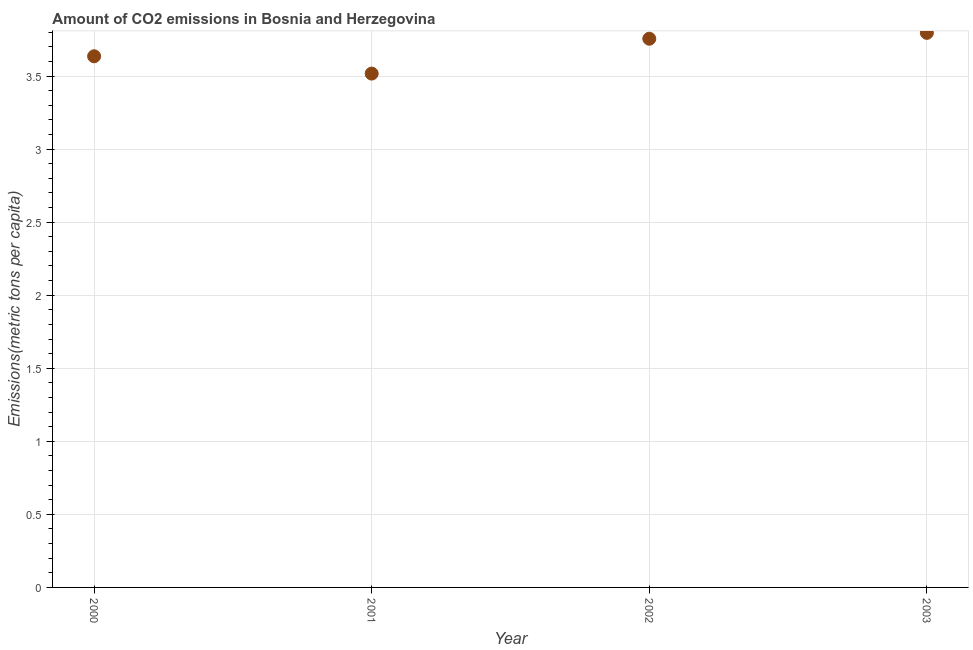What is the amount of co2 emissions in 2000?
Your response must be concise. 3.64. Across all years, what is the maximum amount of co2 emissions?
Your answer should be very brief. 3.8. Across all years, what is the minimum amount of co2 emissions?
Offer a very short reply. 3.52. In which year was the amount of co2 emissions maximum?
Ensure brevity in your answer.  2003. What is the sum of the amount of co2 emissions?
Provide a short and direct response. 14.7. What is the difference between the amount of co2 emissions in 2002 and 2003?
Your response must be concise. -0.04. What is the average amount of co2 emissions per year?
Provide a succinct answer. 3.68. What is the median amount of co2 emissions?
Keep it short and to the point. 3.7. In how many years, is the amount of co2 emissions greater than 1.4 metric tons per capita?
Keep it short and to the point. 4. Do a majority of the years between 2000 and 2002 (inclusive) have amount of co2 emissions greater than 2.8 metric tons per capita?
Provide a succinct answer. Yes. What is the ratio of the amount of co2 emissions in 2001 to that in 2003?
Give a very brief answer. 0.93. Is the amount of co2 emissions in 2001 less than that in 2002?
Offer a very short reply. Yes. What is the difference between the highest and the second highest amount of co2 emissions?
Provide a short and direct response. 0.04. Is the sum of the amount of co2 emissions in 2001 and 2003 greater than the maximum amount of co2 emissions across all years?
Your answer should be compact. Yes. What is the difference between the highest and the lowest amount of co2 emissions?
Your response must be concise. 0.28. In how many years, is the amount of co2 emissions greater than the average amount of co2 emissions taken over all years?
Provide a succinct answer. 2. How many dotlines are there?
Your response must be concise. 1. How many years are there in the graph?
Offer a terse response. 4. What is the difference between two consecutive major ticks on the Y-axis?
Offer a very short reply. 0.5. What is the title of the graph?
Keep it short and to the point. Amount of CO2 emissions in Bosnia and Herzegovina. What is the label or title of the X-axis?
Keep it short and to the point. Year. What is the label or title of the Y-axis?
Provide a short and direct response. Emissions(metric tons per capita). What is the Emissions(metric tons per capita) in 2000?
Provide a short and direct response. 3.64. What is the Emissions(metric tons per capita) in 2001?
Give a very brief answer. 3.52. What is the Emissions(metric tons per capita) in 2002?
Ensure brevity in your answer.  3.76. What is the Emissions(metric tons per capita) in 2003?
Keep it short and to the point. 3.8. What is the difference between the Emissions(metric tons per capita) in 2000 and 2001?
Ensure brevity in your answer.  0.12. What is the difference between the Emissions(metric tons per capita) in 2000 and 2002?
Your response must be concise. -0.12. What is the difference between the Emissions(metric tons per capita) in 2000 and 2003?
Offer a very short reply. -0.16. What is the difference between the Emissions(metric tons per capita) in 2001 and 2002?
Your answer should be very brief. -0.24. What is the difference between the Emissions(metric tons per capita) in 2001 and 2003?
Provide a succinct answer. -0.28. What is the difference between the Emissions(metric tons per capita) in 2002 and 2003?
Your answer should be compact. -0.04. What is the ratio of the Emissions(metric tons per capita) in 2000 to that in 2001?
Keep it short and to the point. 1.03. What is the ratio of the Emissions(metric tons per capita) in 2000 to that in 2003?
Ensure brevity in your answer.  0.96. What is the ratio of the Emissions(metric tons per capita) in 2001 to that in 2002?
Give a very brief answer. 0.94. What is the ratio of the Emissions(metric tons per capita) in 2001 to that in 2003?
Give a very brief answer. 0.93. What is the ratio of the Emissions(metric tons per capita) in 2002 to that in 2003?
Keep it short and to the point. 0.99. 